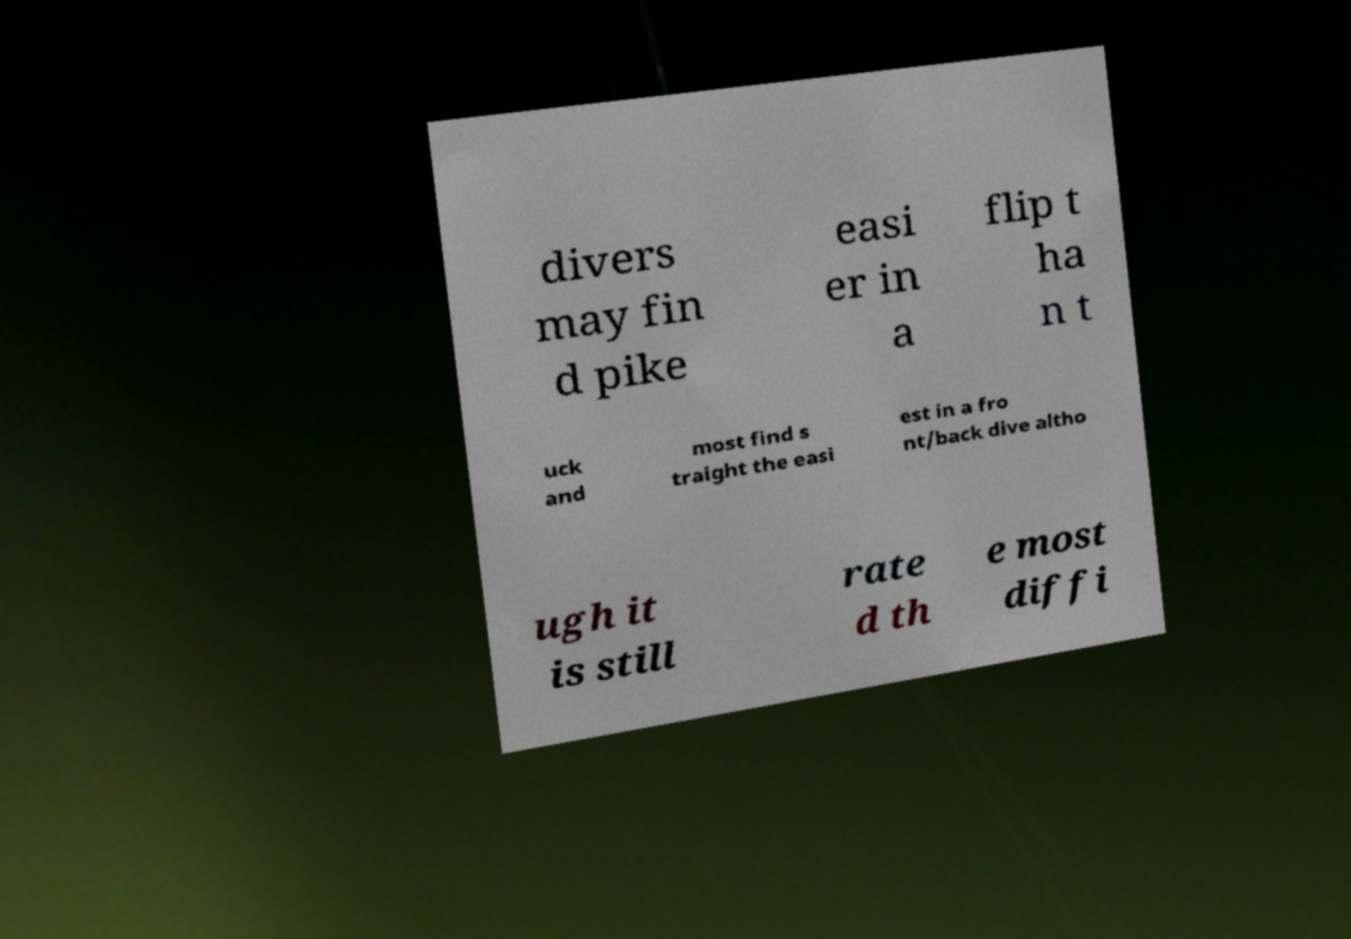I need the written content from this picture converted into text. Can you do that? divers may fin d pike easi er in a flip t ha n t uck and most find s traight the easi est in a fro nt/back dive altho ugh it is still rate d th e most diffi 